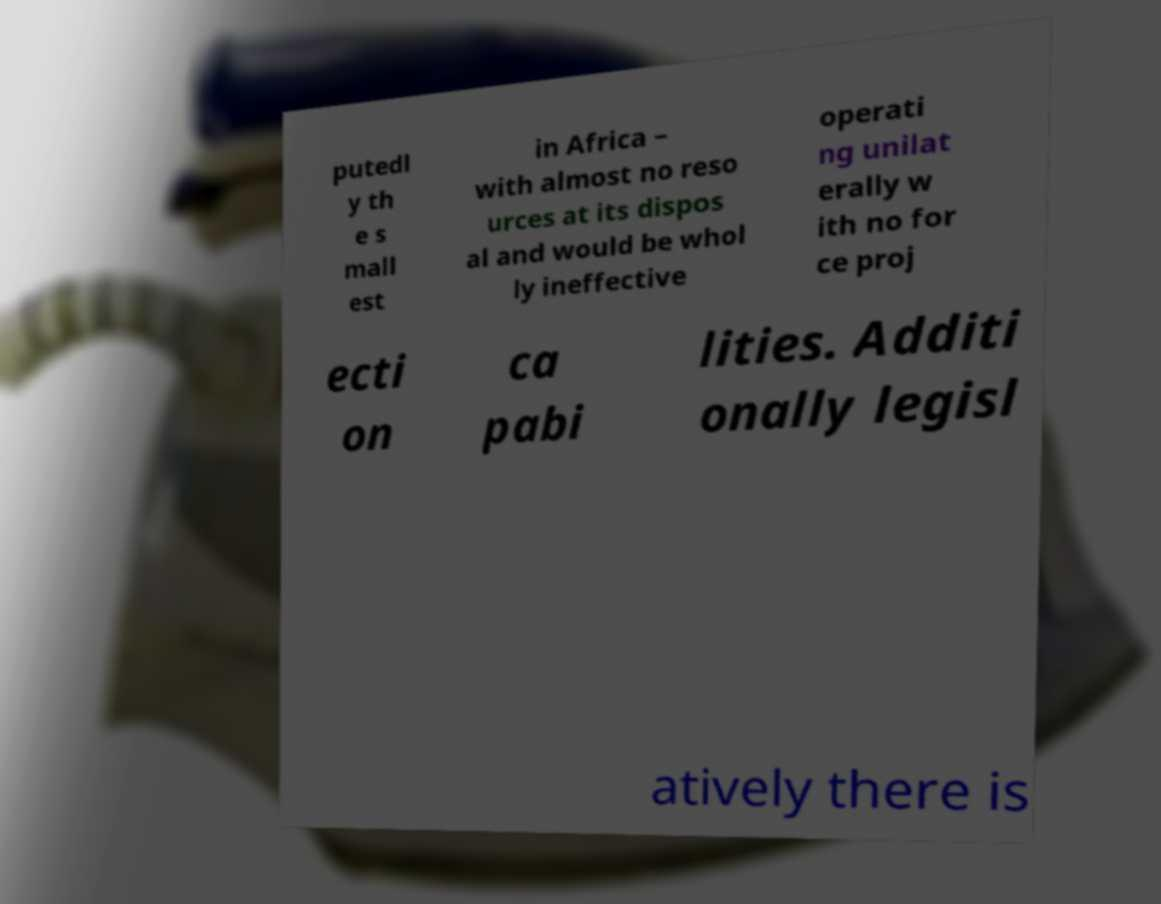For documentation purposes, I need the text within this image transcribed. Could you provide that? putedl y th e s mall est in Africa – with almost no reso urces at its dispos al and would be whol ly ineffective operati ng unilat erally w ith no for ce proj ecti on ca pabi lities. Additi onally legisl atively there is 